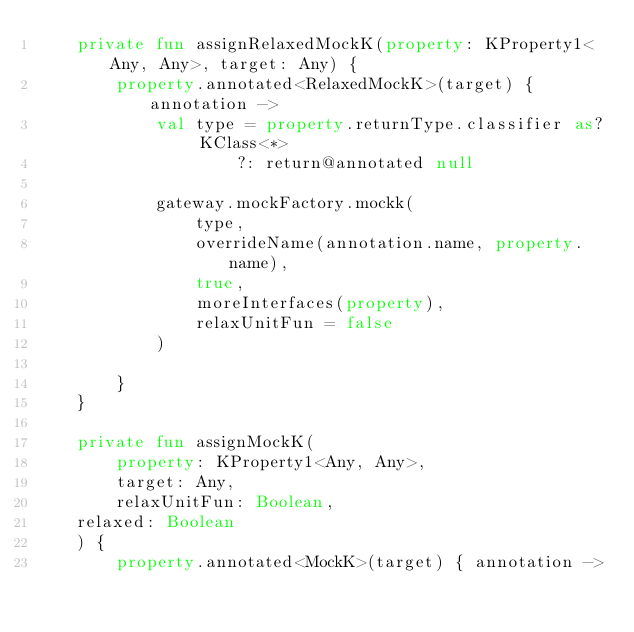<code> <loc_0><loc_0><loc_500><loc_500><_Kotlin_>    private fun assignRelaxedMockK(property: KProperty1<Any, Any>, target: Any) {
        property.annotated<RelaxedMockK>(target) { annotation ->
            val type = property.returnType.classifier as? KClass<*>
                    ?: return@annotated null

            gateway.mockFactory.mockk(
                type,
                overrideName(annotation.name, property.name),
                true,
                moreInterfaces(property),
                relaxUnitFun = false
            )

        }
    }

    private fun assignMockK(
        property: KProperty1<Any, Any>,
        target: Any,
        relaxUnitFun: Boolean,
    relaxed: Boolean
    ) {
        property.annotated<MockK>(target) { annotation -></code> 